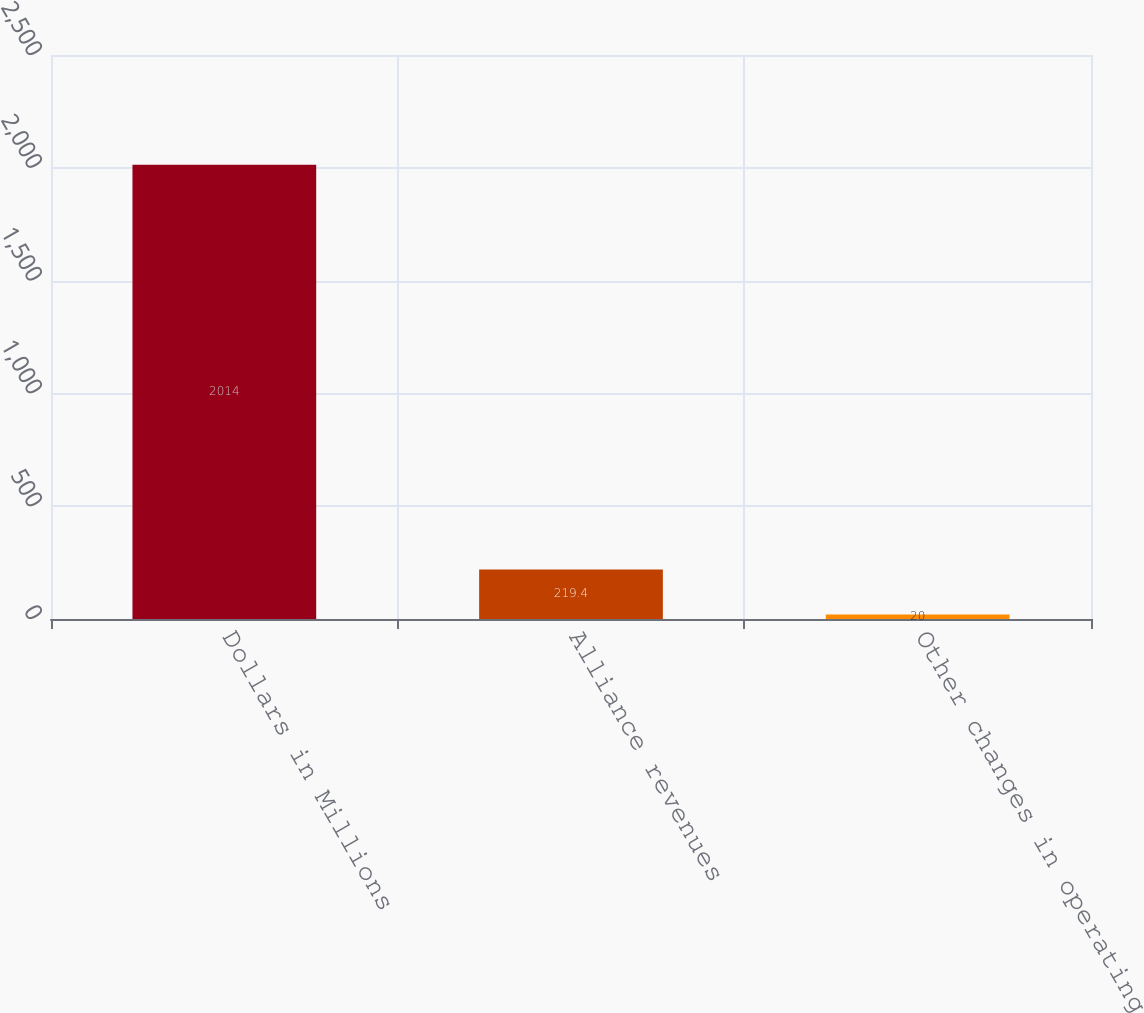Convert chart. <chart><loc_0><loc_0><loc_500><loc_500><bar_chart><fcel>Dollars in Millions<fcel>Alliance revenues<fcel>Other changes in operating<nl><fcel>2014<fcel>219.4<fcel>20<nl></chart> 